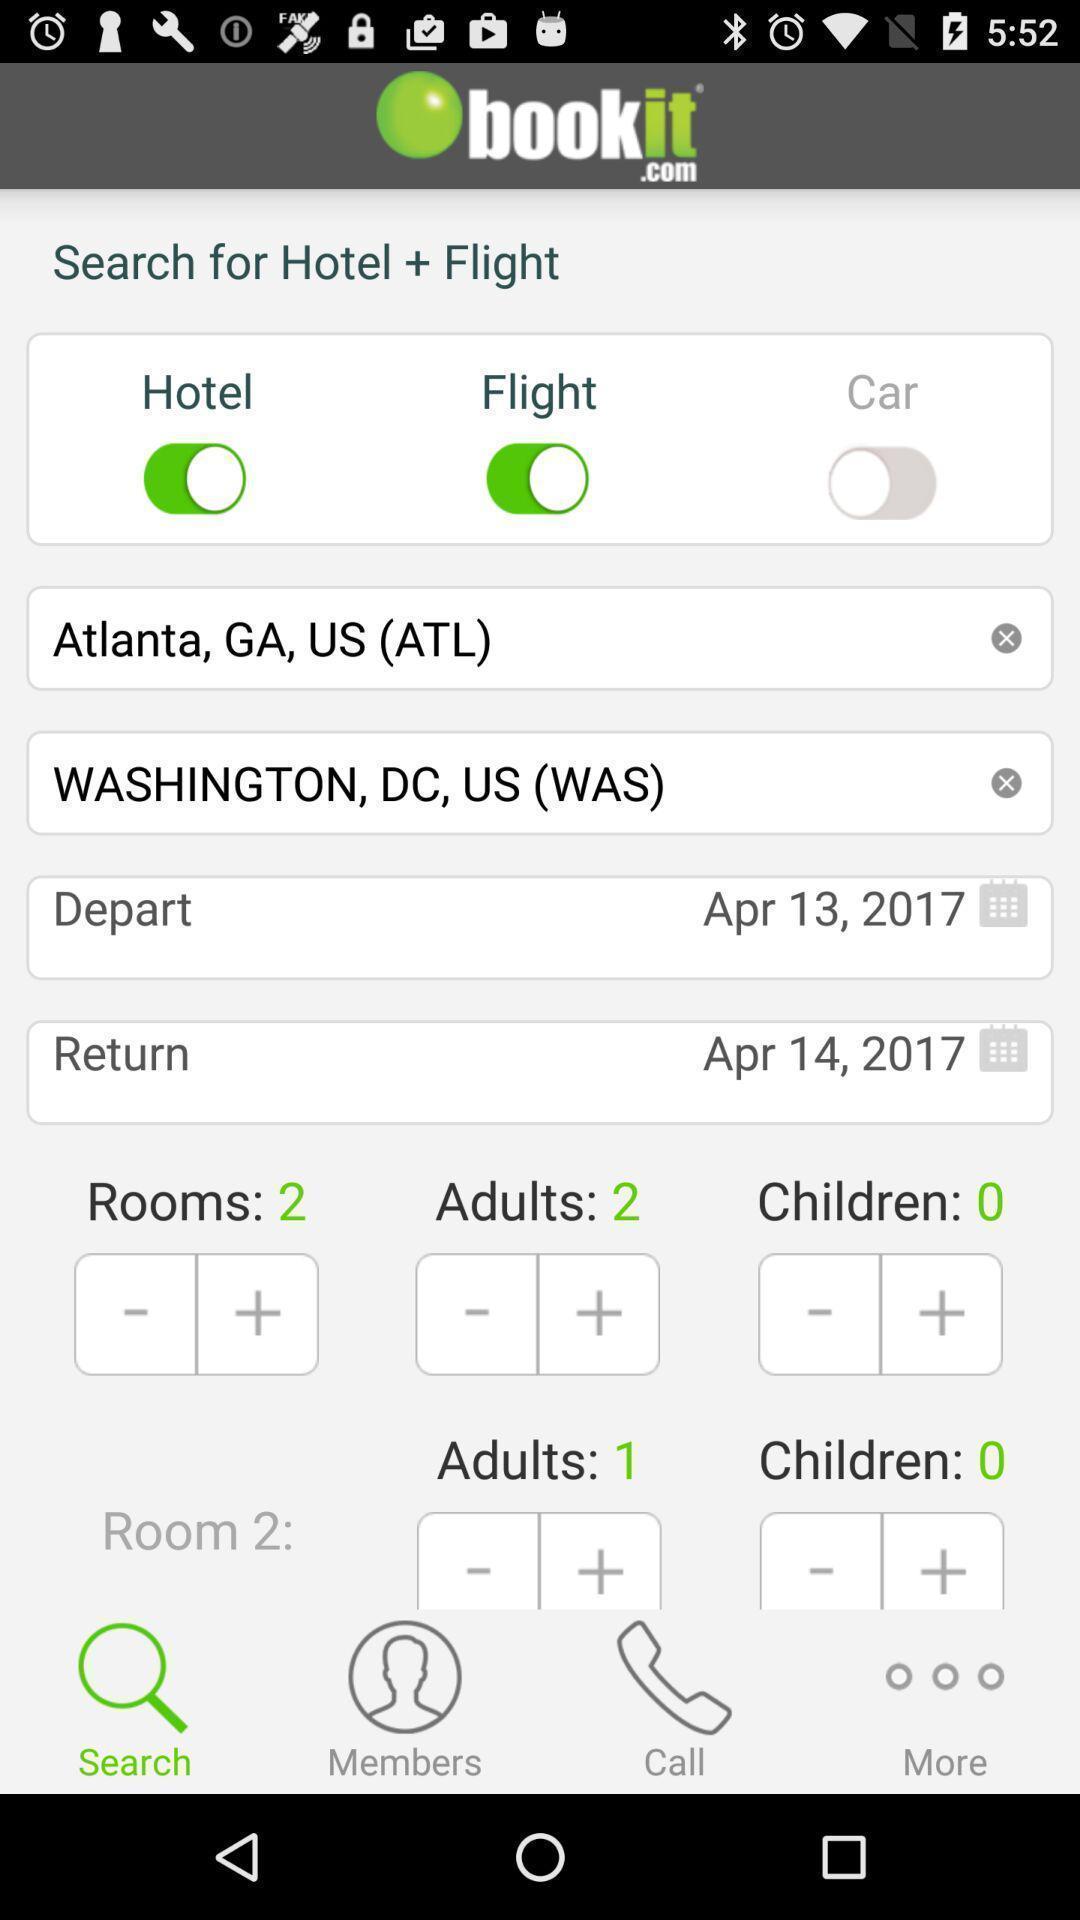Explain the elements present in this screenshot. Search page with booking options in a booking app. 